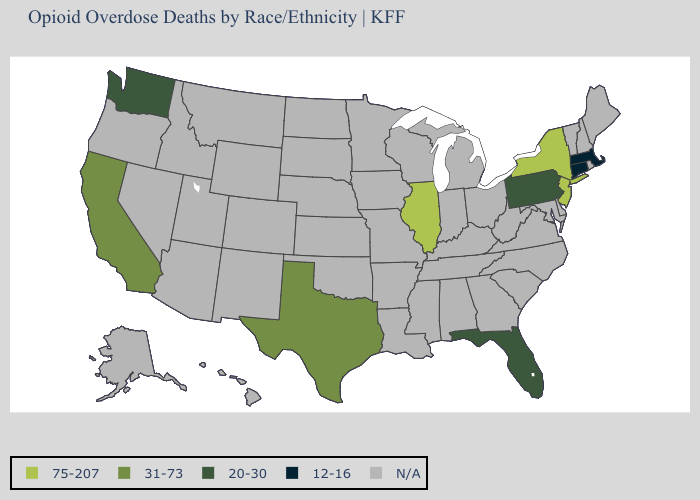Name the states that have a value in the range 75-207?
Answer briefly. Illinois, New Jersey, New York. Does Florida have the lowest value in the USA?
Be succinct. No. Which states have the highest value in the USA?
Be succinct. Illinois, New Jersey, New York. Is the legend a continuous bar?
Short answer required. No. Does Texas have the lowest value in the USA?
Keep it brief. No. Name the states that have a value in the range 20-30?
Keep it brief. Florida, Pennsylvania, Washington. Which states hav the highest value in the West?
Concise answer only. California. Does Washington have the lowest value in the West?
Concise answer only. Yes. Does the first symbol in the legend represent the smallest category?
Quick response, please. No. What is the highest value in the West ?
Quick response, please. 31-73. What is the highest value in states that border Arizona?
Be succinct. 31-73. Name the states that have a value in the range 20-30?
Quick response, please. Florida, Pennsylvania, Washington. What is the value of Maine?
Give a very brief answer. N/A. What is the value of New Mexico?
Concise answer only. N/A. Does the map have missing data?
Short answer required. Yes. 